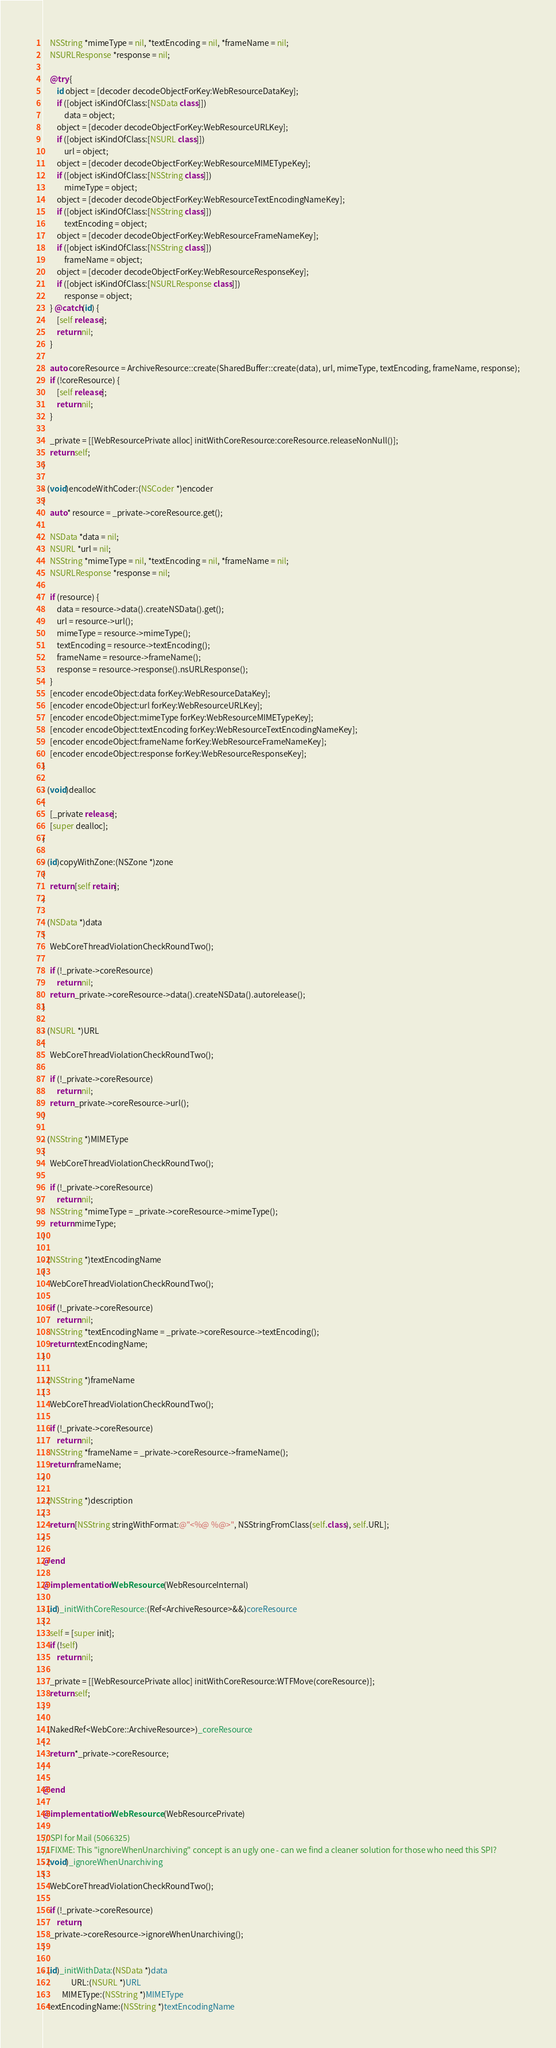Convert code to text. <code><loc_0><loc_0><loc_500><loc_500><_ObjectiveC_>    NSString *mimeType = nil, *textEncoding = nil, *frameName = nil;
    NSURLResponse *response = nil;
    
    @try {
        id object = [decoder decodeObjectForKey:WebResourceDataKey];
        if ([object isKindOfClass:[NSData class]])
            data = object;
        object = [decoder decodeObjectForKey:WebResourceURLKey];
        if ([object isKindOfClass:[NSURL class]])
            url = object;
        object = [decoder decodeObjectForKey:WebResourceMIMETypeKey];
        if ([object isKindOfClass:[NSString class]])
            mimeType = object;
        object = [decoder decodeObjectForKey:WebResourceTextEncodingNameKey];
        if ([object isKindOfClass:[NSString class]])
            textEncoding = object;
        object = [decoder decodeObjectForKey:WebResourceFrameNameKey];
        if ([object isKindOfClass:[NSString class]])
            frameName = object;
        object = [decoder decodeObjectForKey:WebResourceResponseKey];
        if ([object isKindOfClass:[NSURLResponse class]])
            response = object;
    } @catch(id) {
        [self release];
        return nil;
    }

    auto coreResource = ArchiveResource::create(SharedBuffer::create(data), url, mimeType, textEncoding, frameName, response);
    if (!coreResource) {
        [self release];
        return nil;
    }

    _private = [[WebResourcePrivate alloc] initWithCoreResource:coreResource.releaseNonNull()];
    return self;
}

- (void)encodeWithCoder:(NSCoder *)encoder
{
    auto* resource = _private->coreResource.get();
    
    NSData *data = nil;
    NSURL *url = nil;
    NSString *mimeType = nil, *textEncoding = nil, *frameName = nil;
    NSURLResponse *response = nil;
    
    if (resource) {
        data = resource->data().createNSData().get();
        url = resource->url();
        mimeType = resource->mimeType();
        textEncoding = resource->textEncoding();
        frameName = resource->frameName();
        response = resource->response().nsURLResponse();
    }
    [encoder encodeObject:data forKey:WebResourceDataKey];
    [encoder encodeObject:url forKey:WebResourceURLKey];
    [encoder encodeObject:mimeType forKey:WebResourceMIMETypeKey];
    [encoder encodeObject:textEncoding forKey:WebResourceTextEncodingNameKey];
    [encoder encodeObject:frameName forKey:WebResourceFrameNameKey];
    [encoder encodeObject:response forKey:WebResourceResponseKey];
}

- (void)dealloc
{
    [_private release];
    [super dealloc];
}

- (id)copyWithZone:(NSZone *)zone
{
    return [self retain];
}

- (NSData *)data
{
    WebCoreThreadViolationCheckRoundTwo();

    if (!_private->coreResource)
        return nil;
    return _private->coreResource->data().createNSData().autorelease();
}

- (NSURL *)URL
{
    WebCoreThreadViolationCheckRoundTwo();

    if (!_private->coreResource)
        return nil;
    return _private->coreResource->url();
}

- (NSString *)MIMEType
{
    WebCoreThreadViolationCheckRoundTwo();

    if (!_private->coreResource)
        return nil;
    NSString *mimeType = _private->coreResource->mimeType();
    return mimeType;
}

- (NSString *)textEncodingName
{
    WebCoreThreadViolationCheckRoundTwo();

    if (!_private->coreResource)
        return nil;
    NSString *textEncodingName = _private->coreResource->textEncoding();
    return textEncodingName;
}

- (NSString *)frameName
{
    WebCoreThreadViolationCheckRoundTwo();

    if (!_private->coreResource)
        return nil;
    NSString *frameName = _private->coreResource->frameName();
    return frameName;
}

- (NSString *)description
{
    return [NSString stringWithFormat:@"<%@ %@>", NSStringFromClass(self.class), self.URL];
}

@end

@implementation WebResource (WebResourceInternal)

- (id)_initWithCoreResource:(Ref<ArchiveResource>&&)coreResource
{
    self = [super init];
    if (!self)
        return nil;

    _private = [[WebResourcePrivate alloc] initWithCoreResource:WTFMove(coreResource)];
    return self;
}

- (NakedRef<WebCore::ArchiveResource>)_coreResource
{
    return *_private->coreResource;
}

@end

@implementation WebResource (WebResourcePrivate)

// SPI for Mail (5066325)
// FIXME: This "ignoreWhenUnarchiving" concept is an ugly one - can we find a cleaner solution for those who need this SPI?
- (void)_ignoreWhenUnarchiving
{
    WebCoreThreadViolationCheckRoundTwo();

    if (!_private->coreResource)
        return;
    _private->coreResource->ignoreWhenUnarchiving();
}

- (id)_initWithData:(NSData *)data 
                URL:(NSURL *)URL 
           MIMEType:(NSString *)MIMEType 
   textEncodingName:(NSString *)textEncodingName </code> 